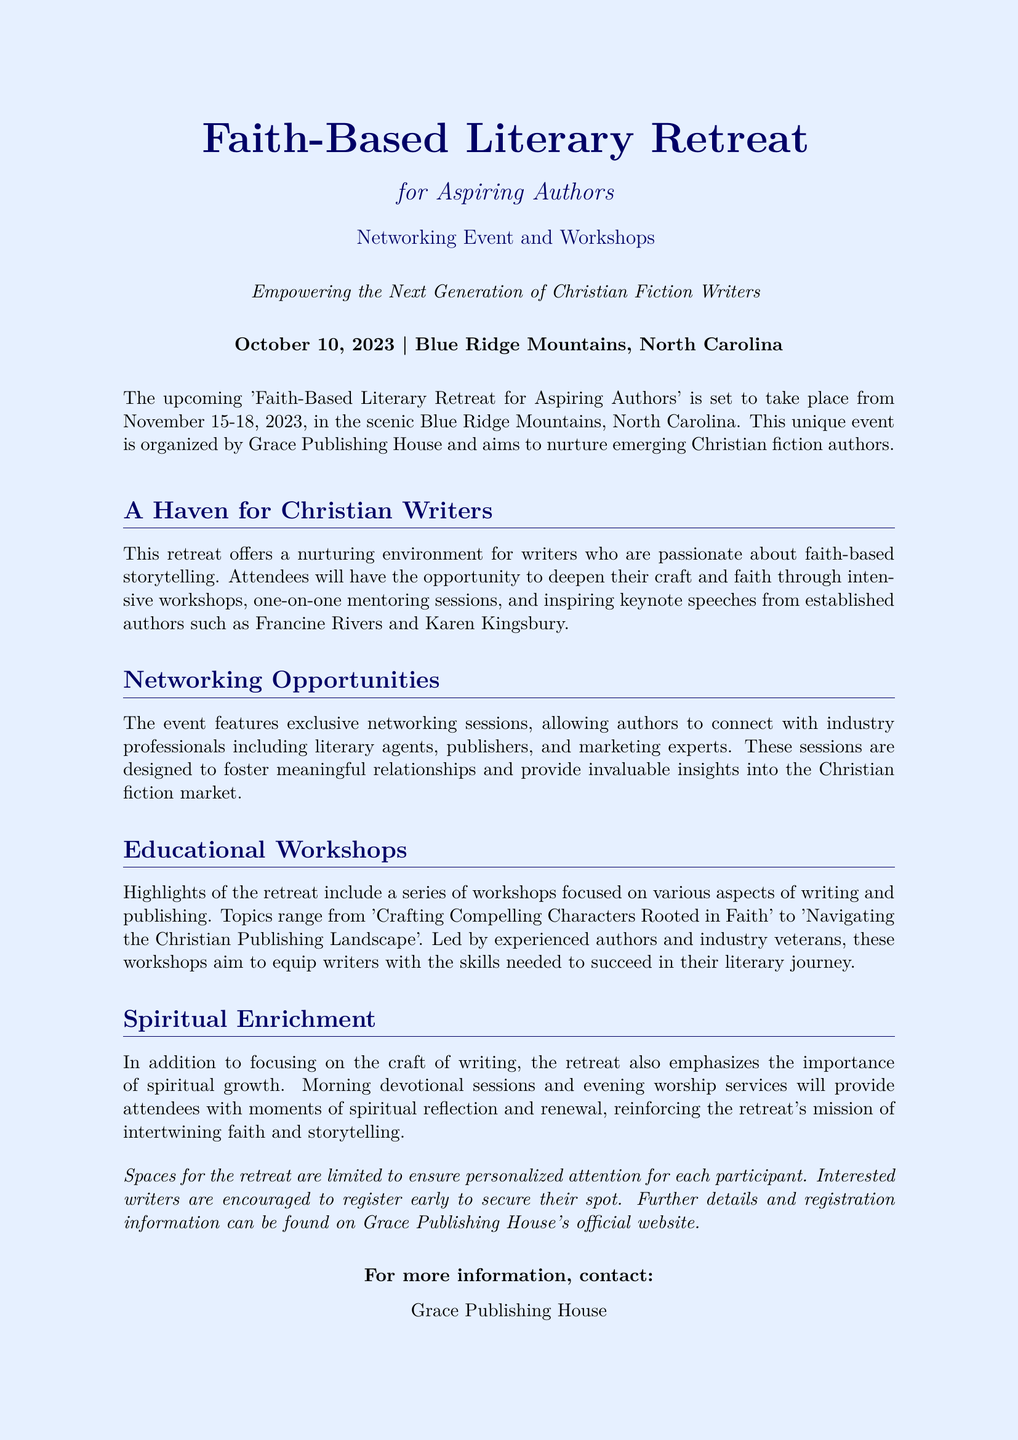What are the dates of the retreat? The dates of the retreat are mentioned in the document as November 15-18, 2023.
Answer: November 15-18, 2023 Who are some of the keynote speakers? The document lists established authors such as Francine Rivers and Karen Kingsbury as keynote speakers.
Answer: Francine Rivers and Karen Kingsbury What is the location of the retreat? The document specifies that the retreat will take place in the Blue Ridge Mountains, North Carolina.
Answer: Blue Ridge Mountains, North Carolina What type of sessions will be offered at the retreat? The document mentions one-on-one mentoring sessions as part of the sessions offered.
Answer: One-on-one mentoring sessions What is the primary aim of the event? The document states that the aim is to nurture emerging Christian fiction authors.
Answer: Nurture emerging Christian fiction authors How many attendees will the retreat accommodate? The document notes that spaces for the retreat are limited, but does not specify a number.
Answer: Limited What topic is covered in the workshops? The document includes a workshop titled 'Crafting Compelling Characters Rooted in Faith'.
Answer: Crafting Compelling Characters Rooted in Faith What type of spiritual activities are included? The document details morning devotional sessions and evening worship services as part of the spiritual activities.
Answer: Morning devotional sessions and evening worship services Who is organizing the retreat? The document states that the retreat is organized by Grace Publishing House.
Answer: Grace Publishing House 